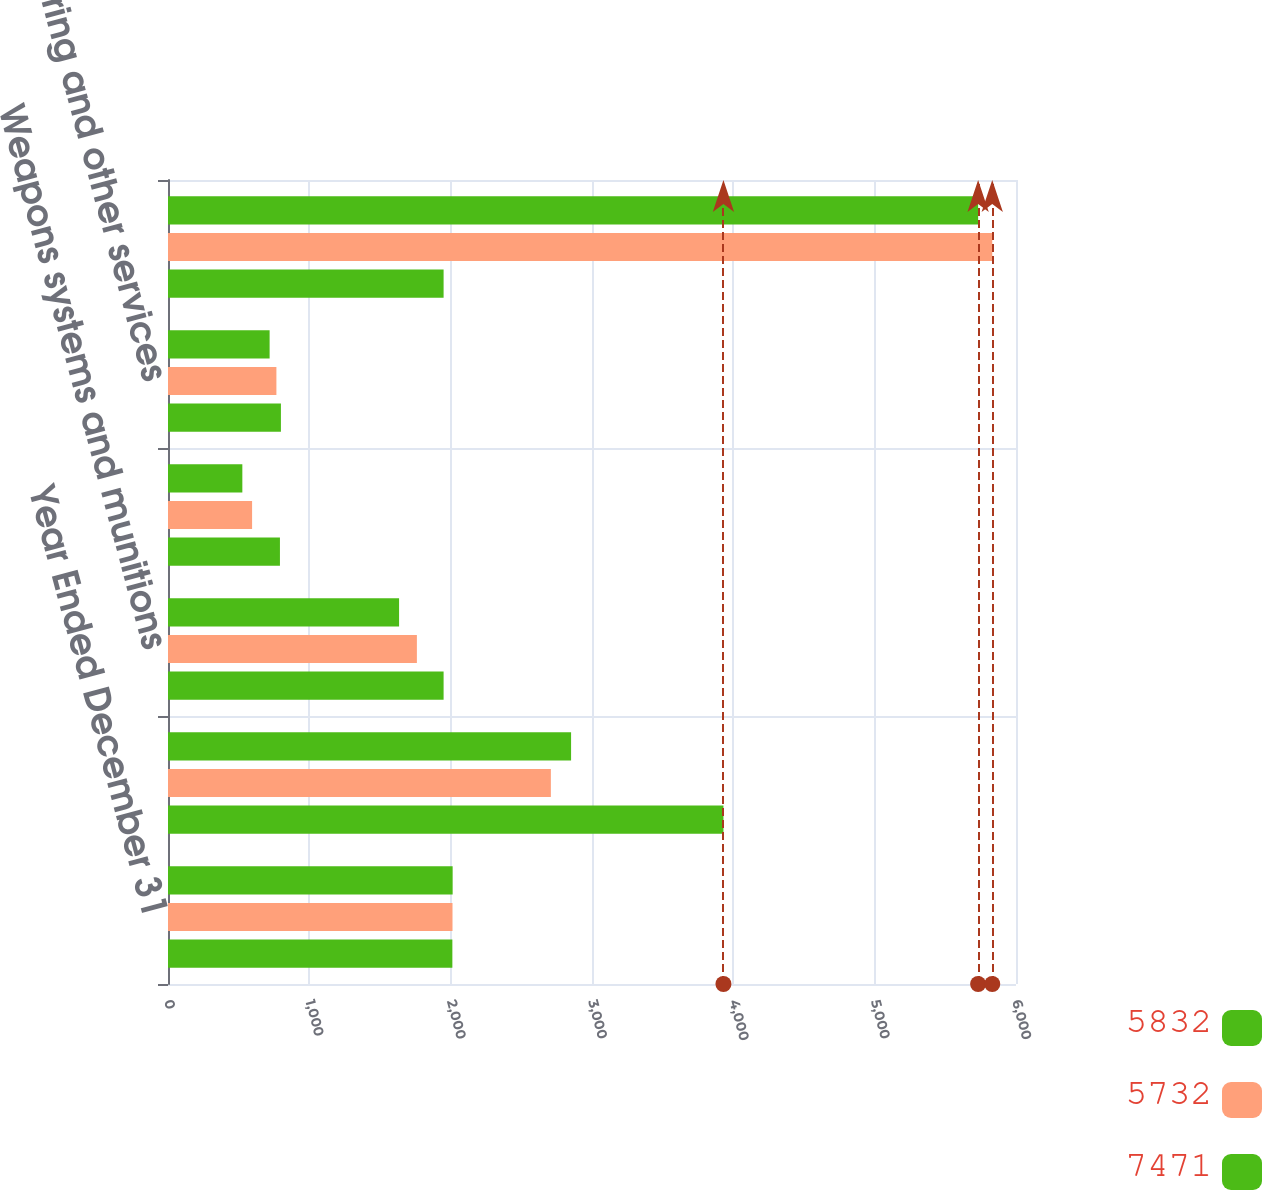Convert chart to OTSL. <chart><loc_0><loc_0><loc_500><loc_500><stacked_bar_chart><ecel><fcel>Year Ended December 31<fcel>Wheeled combat vehicles<fcel>Weapons systems and munitions<fcel>Tanks and tracked vehicles<fcel>Engineering and other services<fcel>Total Combat Systems<nl><fcel>5832<fcel>2014<fcel>2852<fcel>1635<fcel>526<fcel>719<fcel>5732<nl><fcel>5732<fcel>2013<fcel>2709<fcel>1761<fcel>595<fcel>767<fcel>5832<nl><fcel>7471<fcel>2012<fcel>3930<fcel>1950<fcel>792<fcel>799<fcel>1950<nl></chart> 